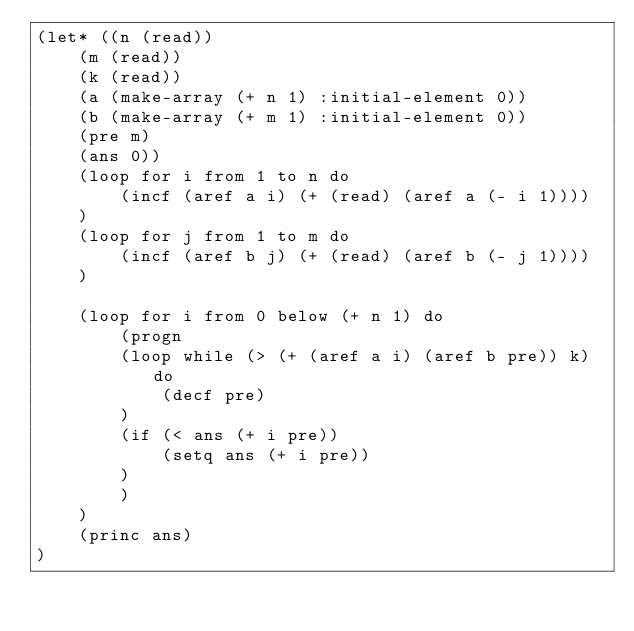<code> <loc_0><loc_0><loc_500><loc_500><_Lisp_>(let* ((n (read))
    (m (read))
    (k (read))
    (a (make-array (+ n 1) :initial-element 0))
    (b (make-array (+ m 1) :initial-element 0))
    (pre m)
    (ans 0))
    (loop for i from 1 to n do
        (incf (aref a i) (+ (read) (aref a (- i 1))))
    )
    (loop for j from 1 to m do
        (incf (aref b j) (+ (read) (aref b (- j 1))))
    )

    (loop for i from 0 below (+ n 1) do
        (progn
        (loop while (> (+ (aref a i) (aref b pre)) k) do
            (decf pre)
        )
        (if (< ans (+ i pre))
            (setq ans (+ i pre))
        )
        )
    )
    (princ ans)
)</code> 